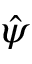<formula> <loc_0><loc_0><loc_500><loc_500>\hat { \psi }</formula> 